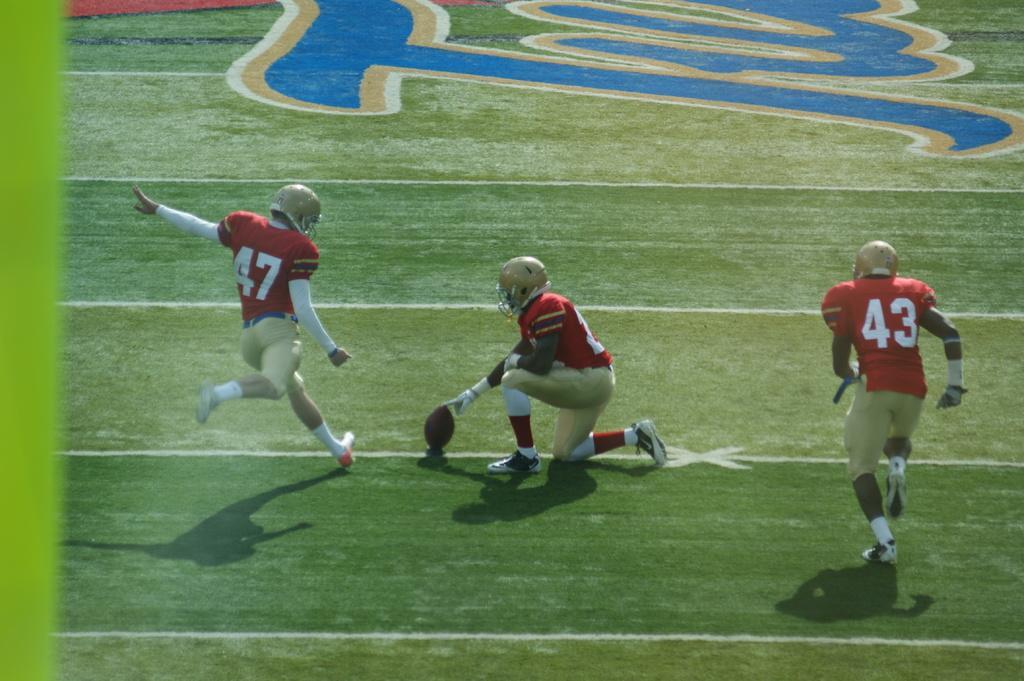Please provide a concise description of this image. In this image players are playing football on the ground. 